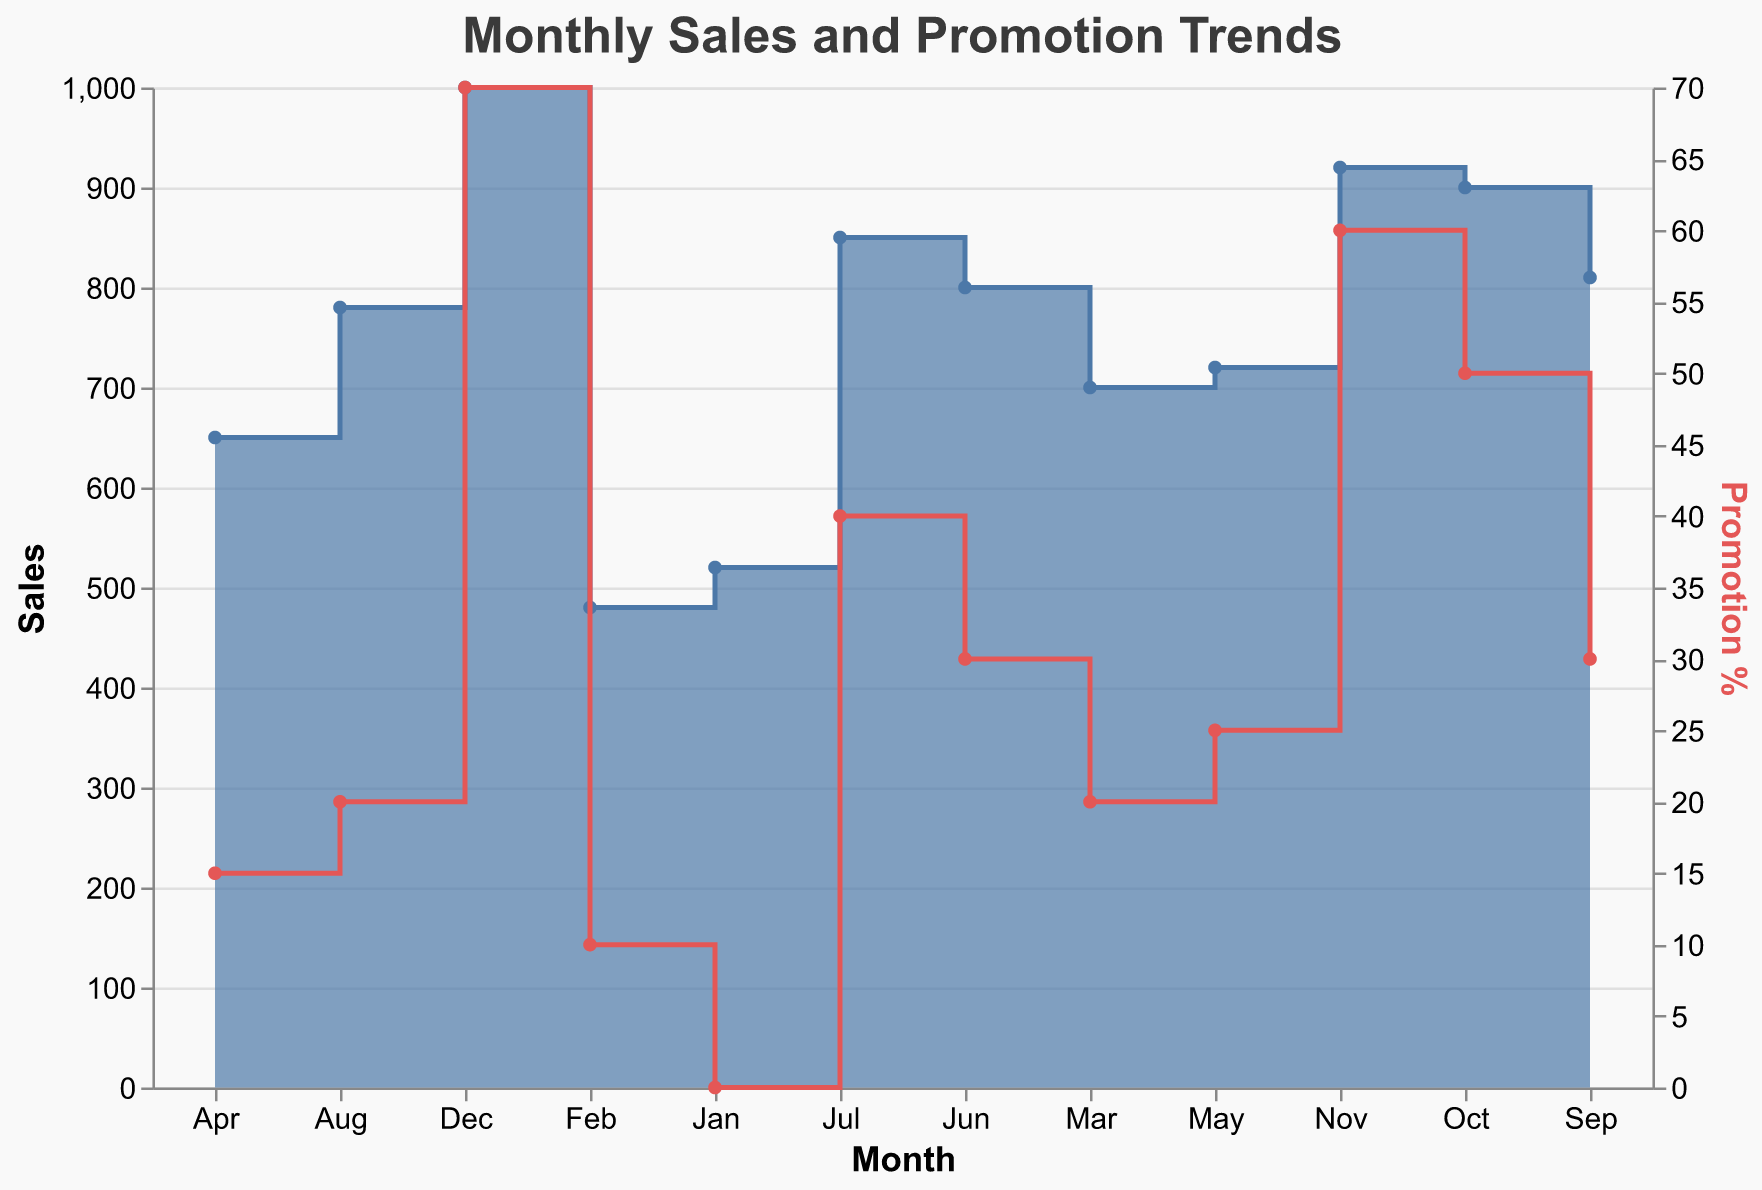What is the title of the figure? The title can be found at the top of the figure. It summarizes the main content the chart represents.
Answer: Monthly Sales and Promotion Trends How many data points are there in the figure? Count each month from January to December. Each month represents one data point in the figure.
Answer: 12 In which month do the sales reach their maximum value? Locate the peak of the blue step area. The maximum value corresponds to the highest point in the step area.
Answer: December What is the trend in promotions from January to December? Observe the red step line on the figure. Check whether it generally increases, decreases, or remains constant over the months.
Answer: Increasing Which month had the biggest change in sales compared to the previous month? Identify the steepest vertical step in the blue step area. Calculate the difference in sales values between consecutive months to confirm.
Answer: February to March What is the difference in sales between the month with the highest promotion and the month with the lowest promotion? Identify that highest promotion (December) and lowest promotion (January) months. Calculate the sales difference between these months.
Answer: 480 Which month had higher sales: August or September? Compare the height of the blue step area at August and September. The month with the taller blue area has higher sales.
Answer: September What is the average sales value across the entire year? Sum up the sales values for each month from January to December, then divide the total by 12.
Answer: 758.33 During which months did the promotion reach 50% or more? Analyze the red step line and identify the months where the promotion value is 50% or higher (October, November, December).
Answer: October, November, December 